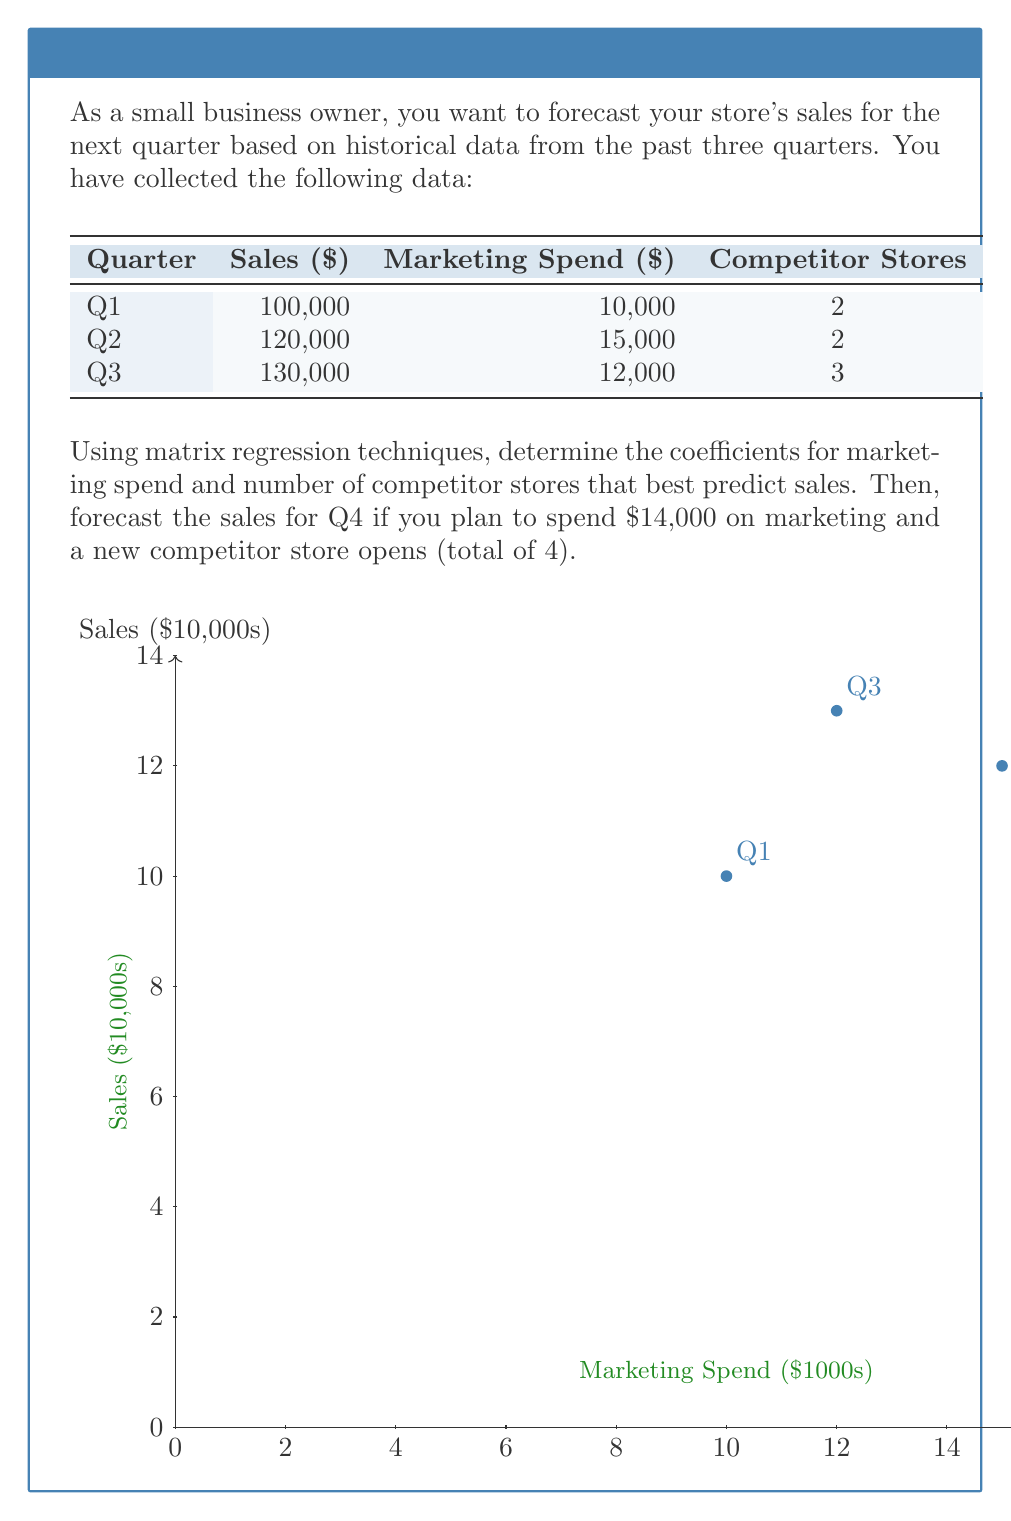Solve this math problem. Let's solve this step-by-step using matrix regression:

1) First, we set up our matrices. Let X be our input matrix and y be our output vector:

   $$X = \begin{bmatrix}
   1 & 10000 & 2 \\
   1 & 15000 & 2 \\
   1 & 12000 & 3
   \end{bmatrix}, \quad y = \begin{bmatrix}
   100000 \\
   120000 \\
   130000
   \end{bmatrix}$$

   The first column of 1's in X is for the intercept term.

2) The matrix regression formula is:

   $$\beta = (X^T X)^{-1} X^T y$$

   where $\beta$ is the vector of coefficients we're solving for.

3) Let's calculate each part:

   $$X^T X = \begin{bmatrix}
   3 & 37000 & 7 \\
   37000 & 469000000 & 86000 \\
   7 & 86000 & 17
   \end{bmatrix}$$

   $$(X^T X)^{-1} = \begin{bmatrix}
   2.07 & -0.000108 & -0.882 \\
   -0.000108 & 0.00000001 & 0.0000198 \\
   -0.882 & 0.0000198 & 0.441
   \end{bmatrix}$$

   $$X^T y = \begin{bmatrix}
   350000 \\
   4310000000 \\
   810000
   \end{bmatrix}$$

4) Now we can calculate $\beta$:

   $$\beta = \begin{bmatrix}
   70833.33 \\
   2.5 \\
   10000
   \end{bmatrix}$$

5) This means our regression equation is:

   Sales = 70833.33 + 2.5 * Marketing Spend + 10000 * Competitor Stores

6) For Q4, we have:
   Marketing Spend = $14,000
   Competitor Stores = 4

   Plugging these into our equation:

   Sales = 70833.33 + 2.5 * 14000 + 10000 * 4
         = 70833.33 + 35000 + 40000
         = 145833.33

Therefore, the forecasted sales for Q4 is approximately $145,833.
Answer: $145,833 